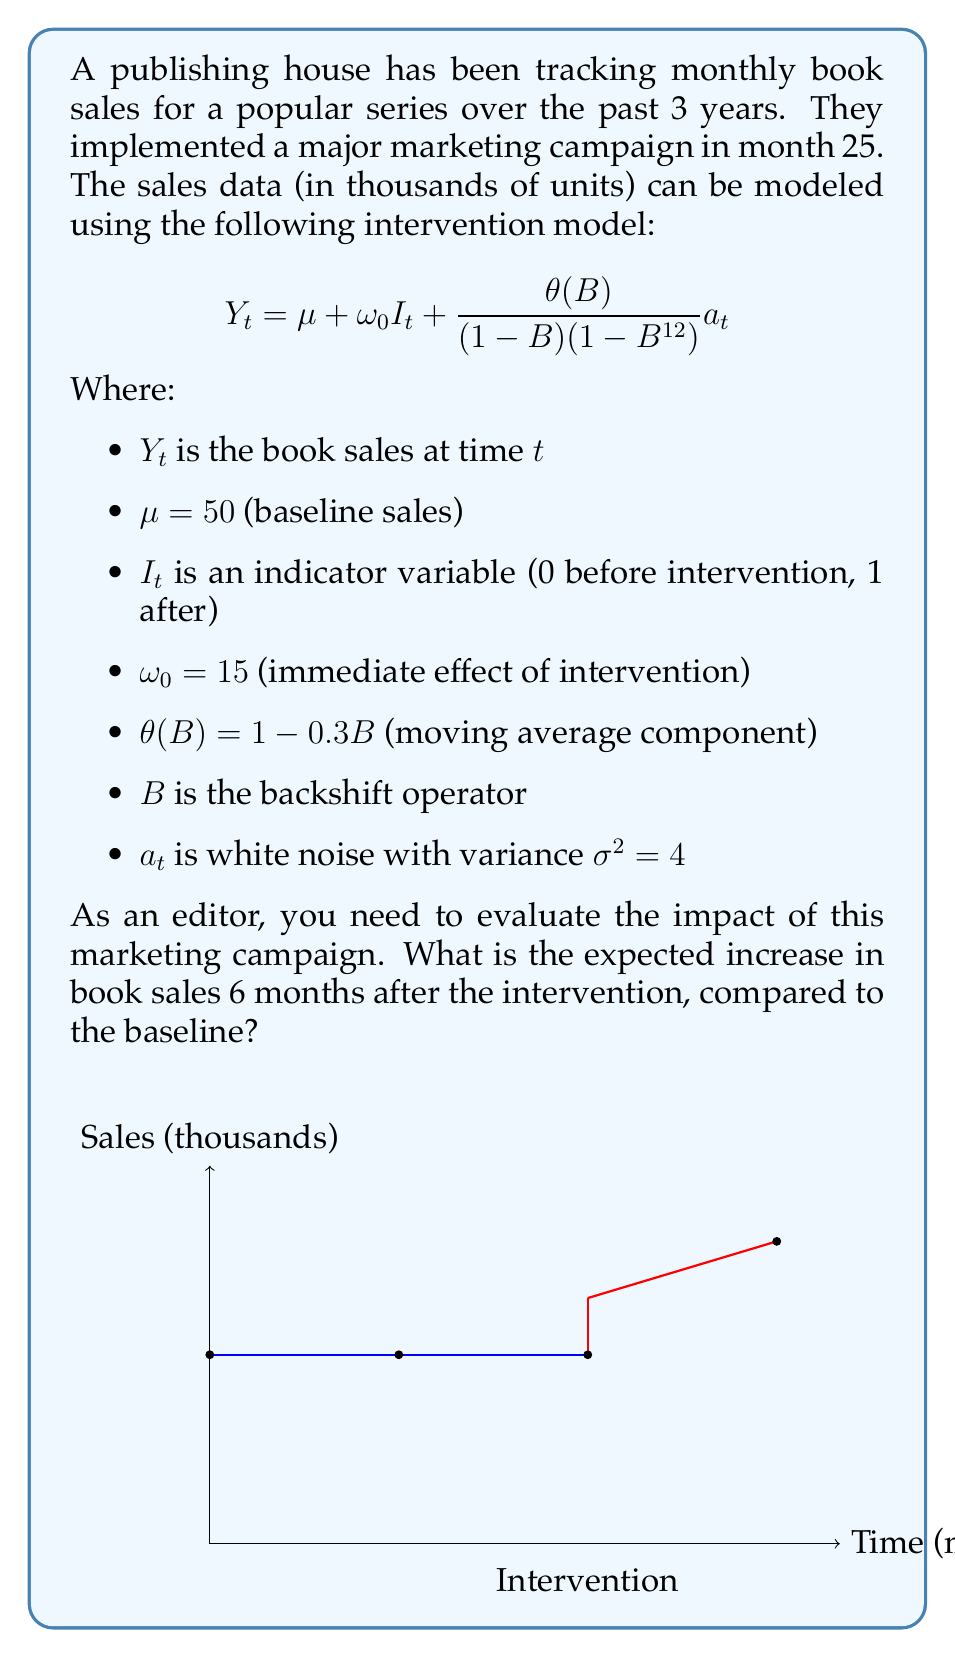What is the answer to this math problem? To evaluate the impact of the marketing campaign, we need to calculate the expected increase in book sales 6 months after the intervention. Let's break this down step-by-step:

1) The intervention model is given by:
   $$Y_t = \mu + \omega_0 I_t + \frac{\theta(B)}{(1-B)(1-B^{12})} a_t$$

2) We're interested in the deterministic part of the model, which is:
   $$E[Y_t] = \mu + \omega_0 I_t$$

3) Before the intervention (baseline):
   $$E[Y_t] = \mu = 50$$

4) Immediately after the intervention (t = 25):
   $$E[Y_{25}] = \mu + \omega_0 = 50 + 15 = 65$$

5) The question asks for the expected increase 6 months after the intervention (t = 31). Since there's no decay factor in the intervention effect, the expected sales will remain at the same level:
   $$E[Y_{31}] = \mu + \omega_0 = 50 + 15 = 65$$

6) To find the increase compared to the baseline, we subtract:
   $$\text{Increase} = E[Y_{31}] - E[Y_t \text{ (before intervention)}] = 65 - 50 = 15$$

Therefore, the expected increase in book sales 6 months after the intervention, compared to the baseline, is 15 thousand units.
Answer: 15 thousand units 